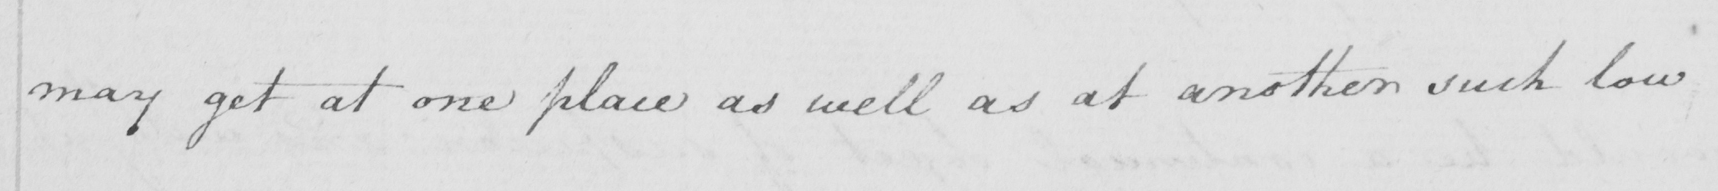Transcribe the text shown in this historical manuscript line. may get at one place as well as at another such low 